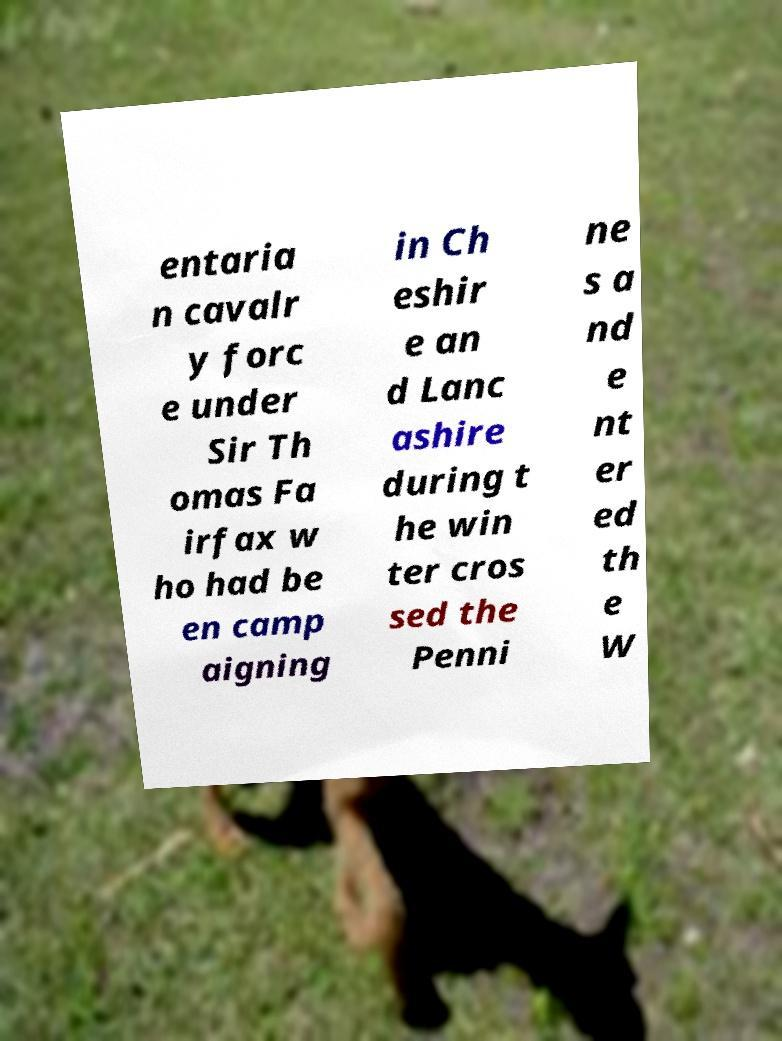Can you accurately transcribe the text from the provided image for me? entaria n cavalr y forc e under Sir Th omas Fa irfax w ho had be en camp aigning in Ch eshir e an d Lanc ashire during t he win ter cros sed the Penni ne s a nd e nt er ed th e W 